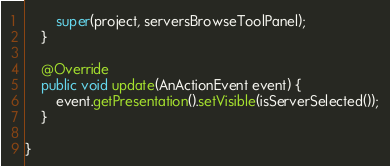Convert code to text. <code><loc_0><loc_0><loc_500><loc_500><_Java_>        super(project, serversBrowseToolPanel);
    }

    @Override
    public void update(AnActionEvent event) {
        event.getPresentation().setVisible(isServerSelected());
    }

}
</code> 